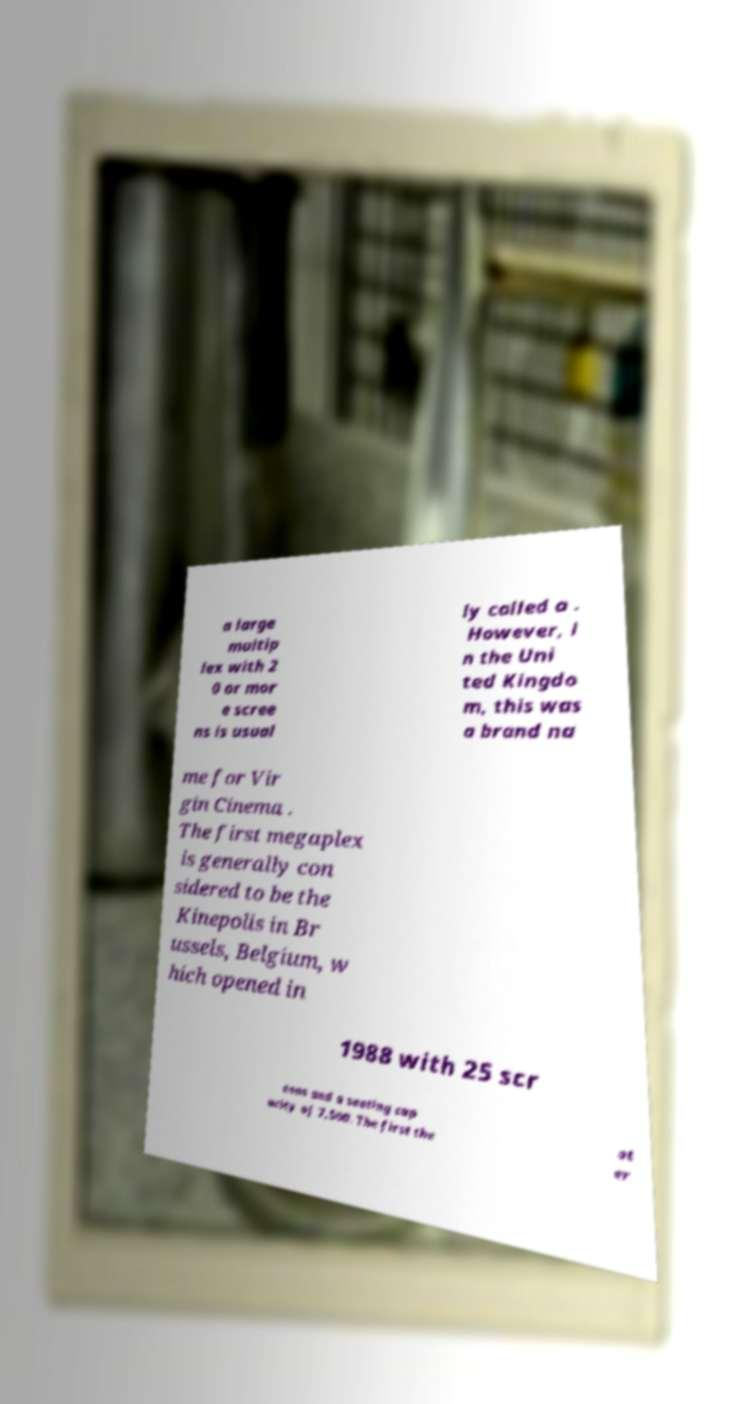Please read and relay the text visible in this image. What does it say? a large multip lex with 2 0 or mor e scree ns is usual ly called a . However, i n the Uni ted Kingdo m, this was a brand na me for Vir gin Cinema . The first megaplex is generally con sidered to be the Kinepolis in Br ussels, Belgium, w hich opened in 1988 with 25 scr eens and a seating cap acity of 7,500. The first the at er 